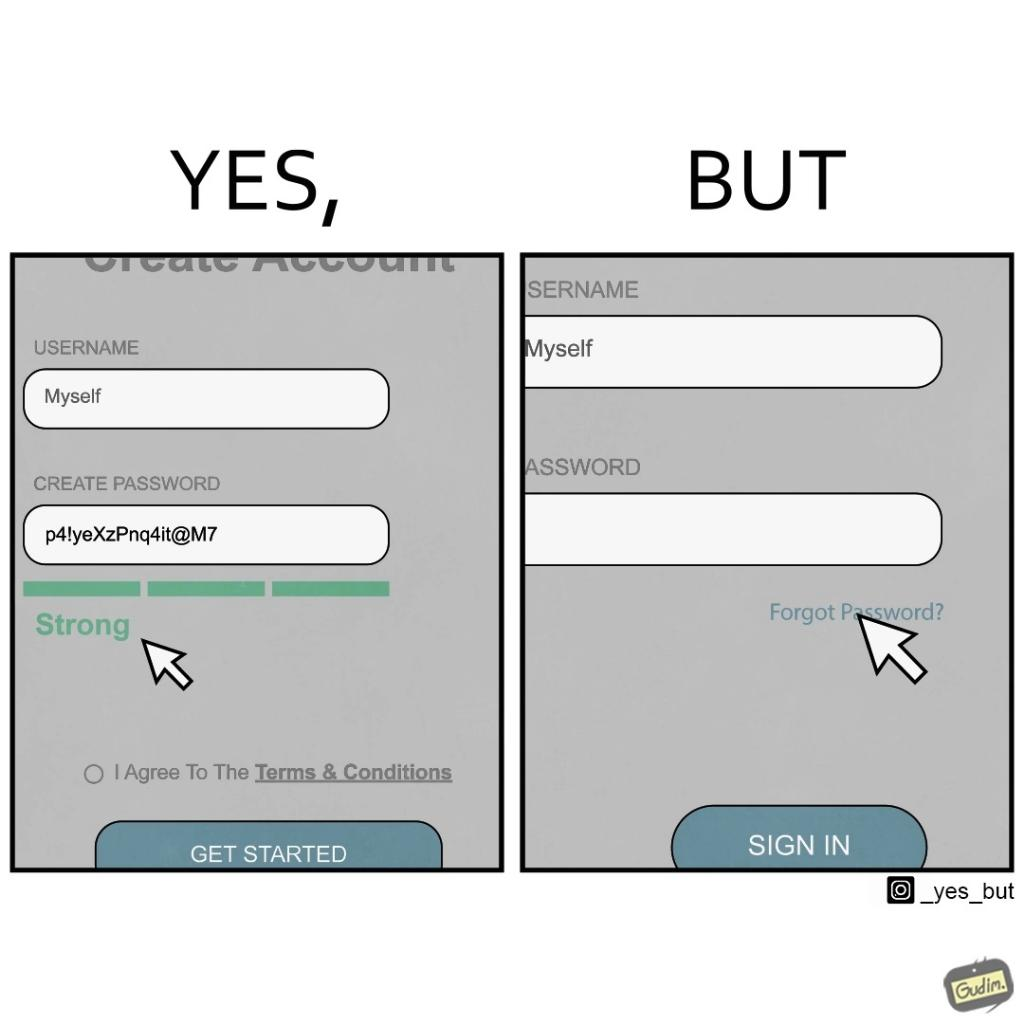Describe what you see in this image. The image is ironic, because people set such a strong passwords for their accounts that they even forget the password and need to reset them 